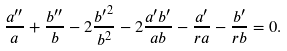Convert formula to latex. <formula><loc_0><loc_0><loc_500><loc_500>\frac { a ^ { \prime \prime } } { a } + \frac { b ^ { \prime \prime } } { b } - 2 \frac { { b ^ { \prime } } ^ { 2 } } { b ^ { 2 } } - 2 \frac { a ^ { \prime } b ^ { \prime } } { a b } - \frac { a ^ { \prime } } { r a } - \frac { b ^ { \prime } } { r b } = 0 .</formula> 